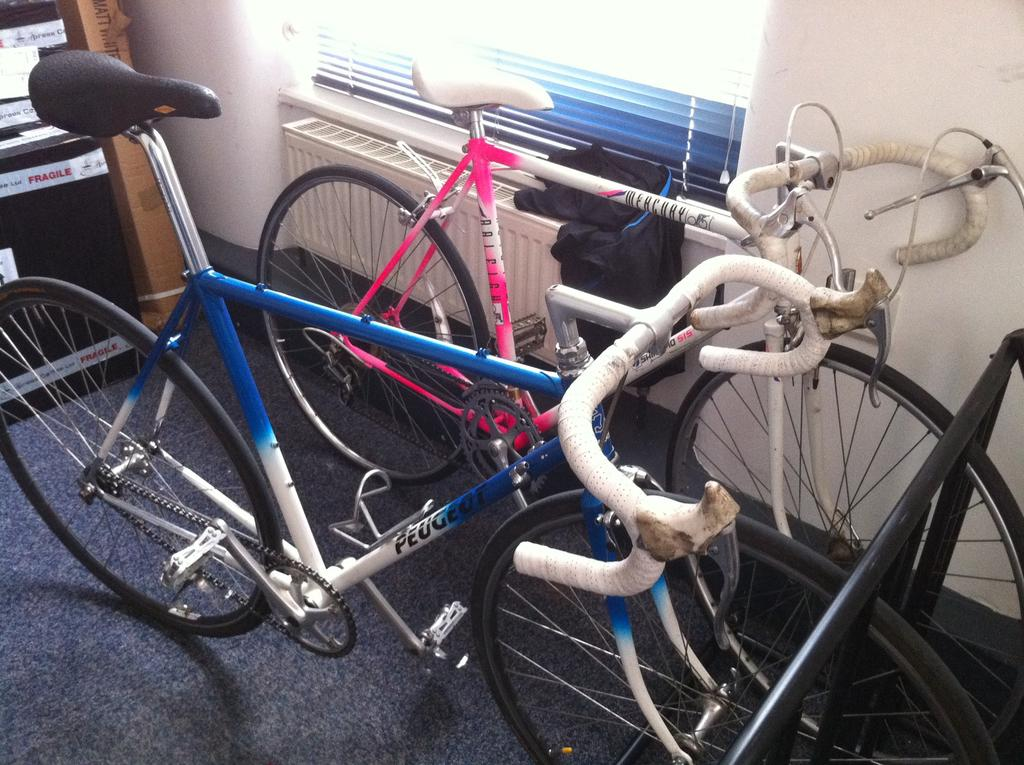What are the colors of the cycles in the image? There is a blue cycle and a pink cycle in the image. Can you describe the cycles in more detail? Unfortunately, the provided facts do not give any additional details about the cycles. What type of show is being performed on the camp's stage in the image? There is no mention of a camp, stage, or show in the provided facts. The image only features a blue cycle and a pink cycle. 